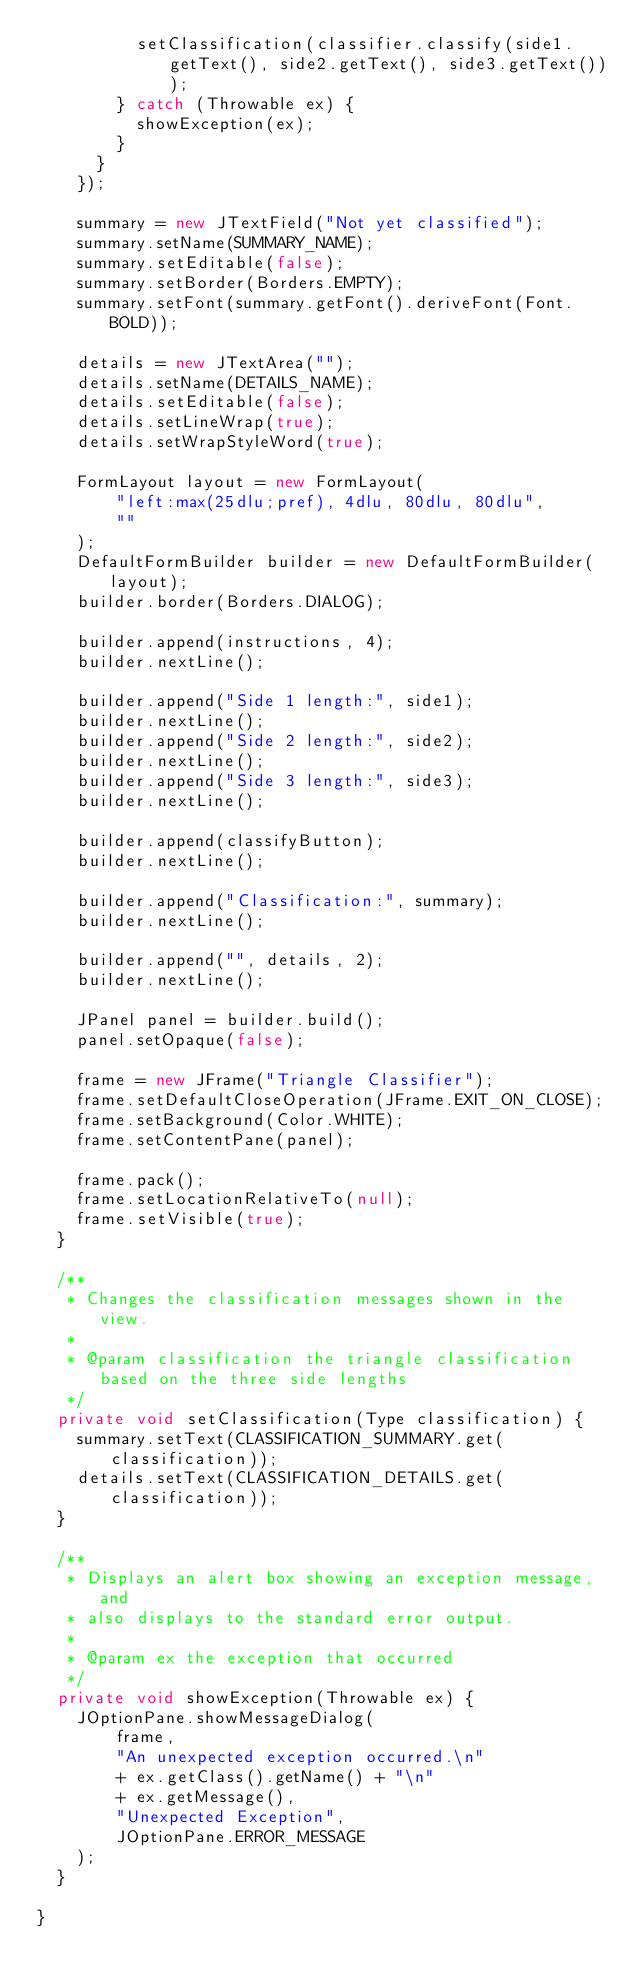Convert code to text. <code><loc_0><loc_0><loc_500><loc_500><_Java_>					setClassification(classifier.classify(side1.getText(), side2.getText(), side3.getText()));
				} catch (Throwable ex) {
					showException(ex);
				}
			}
		});
		
		summary = new JTextField("Not yet classified");
		summary.setName(SUMMARY_NAME);
		summary.setEditable(false);
		summary.setBorder(Borders.EMPTY);
		summary.setFont(summary.getFont().deriveFont(Font.BOLD));

		details = new JTextArea("");
		details.setName(DETAILS_NAME);
		details.setEditable(false);
		details.setLineWrap(true);
		details.setWrapStyleWord(true);
		
		FormLayout layout = new FormLayout(
				"left:max(25dlu;pref), 4dlu, 80dlu, 80dlu",
				""
		);
		DefaultFormBuilder builder = new DefaultFormBuilder(layout);
		builder.border(Borders.DIALOG);
		
		builder.append(instructions, 4);
		builder.nextLine();

		builder.append("Side 1 length:", side1);
		builder.nextLine();
		builder.append("Side 2 length:", side2);
		builder.nextLine();
		builder.append("Side 3 length:", side3);
		builder.nextLine();
		
		builder.append(classifyButton);
		builder.nextLine();
		
		builder.append("Classification:", summary);
		builder.nextLine();
		
		builder.append("", details, 2);
		builder.nextLine();
		
		JPanel panel = builder.build();
		panel.setOpaque(false);
		
		frame = new JFrame("Triangle Classifier");
		frame.setDefaultCloseOperation(JFrame.EXIT_ON_CLOSE);
		frame.setBackground(Color.WHITE);
		frame.setContentPane(panel);
		
		frame.pack();
		frame.setLocationRelativeTo(null);
		frame.setVisible(true);
	}

	/**
	 * Changes the classification messages shown in the view.
	 * 
	 * @param classification the triangle classification based on the three side lengths
	 */
	private void setClassification(Type classification) {
		summary.setText(CLASSIFICATION_SUMMARY.get(classification));
		details.setText(CLASSIFICATION_DETAILS.get(classification));
	}

	/**
	 * Displays an alert box showing an exception message, and
	 * also displays to the standard error output.
	 * 
	 * @param ex the exception that occurred
	 */
	private void showException(Throwable ex) {
		JOptionPane.showMessageDialog(
				frame,
				"An unexpected exception occurred.\n"
				+ ex.getClass().getName() + "\n"
				+ ex.getMessage(),
				"Unexpected Exception",
				JOptionPane.ERROR_MESSAGE
		);
	}

}
</code> 